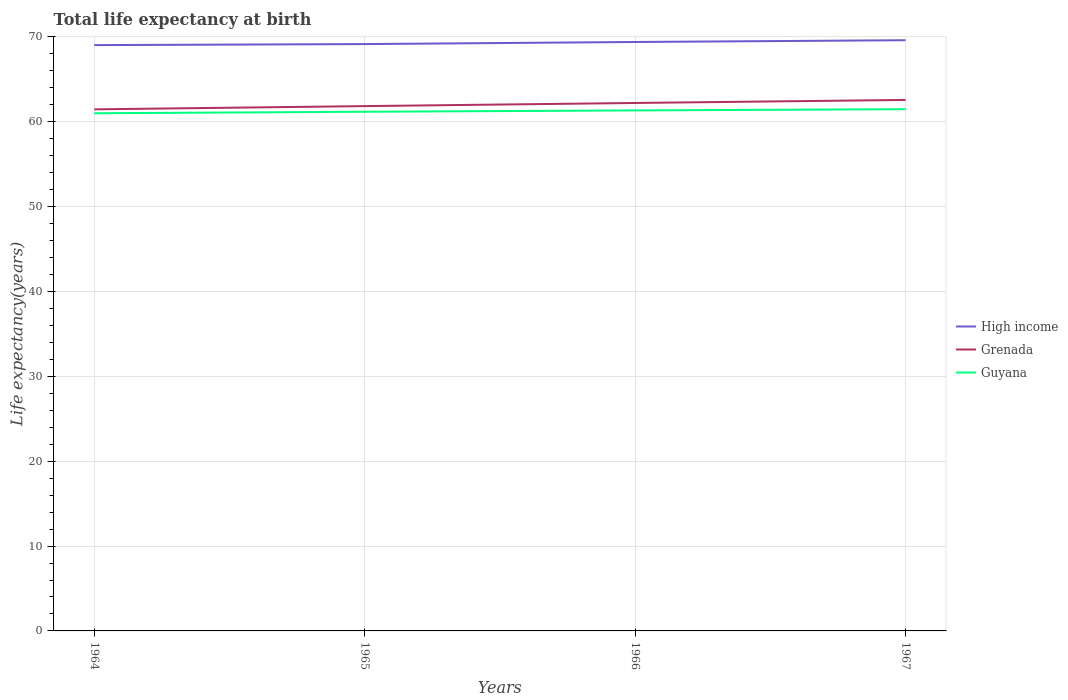Does the line corresponding to High income intersect with the line corresponding to Grenada?
Your answer should be very brief. No. Across all years, what is the maximum life expectancy at birth in in High income?
Provide a short and direct response. 69.04. In which year was the life expectancy at birth in in High income maximum?
Give a very brief answer. 1964. What is the total life expectancy at birth in in Guyana in the graph?
Provide a succinct answer. -0.3. What is the difference between the highest and the second highest life expectancy at birth in in High income?
Ensure brevity in your answer.  0.58. Is the life expectancy at birth in in Grenada strictly greater than the life expectancy at birth in in Guyana over the years?
Provide a short and direct response. No. How many lines are there?
Your answer should be very brief. 3. How many years are there in the graph?
Keep it short and to the point. 4. What is the difference between two consecutive major ticks on the Y-axis?
Make the answer very short. 10. Does the graph contain any zero values?
Make the answer very short. No. How many legend labels are there?
Keep it short and to the point. 3. How are the legend labels stacked?
Offer a terse response. Vertical. What is the title of the graph?
Make the answer very short. Total life expectancy at birth. Does "Iceland" appear as one of the legend labels in the graph?
Your answer should be compact. No. What is the label or title of the Y-axis?
Offer a terse response. Life expectancy(years). What is the Life expectancy(years) of High income in 1964?
Make the answer very short. 69.04. What is the Life expectancy(years) in Grenada in 1964?
Provide a short and direct response. 61.47. What is the Life expectancy(years) in Guyana in 1964?
Give a very brief answer. 61.01. What is the Life expectancy(years) in High income in 1965?
Keep it short and to the point. 69.16. What is the Life expectancy(years) in Grenada in 1965?
Your response must be concise. 61.85. What is the Life expectancy(years) of Guyana in 1965?
Give a very brief answer. 61.19. What is the Life expectancy(years) of High income in 1966?
Offer a terse response. 69.41. What is the Life expectancy(years) of Grenada in 1966?
Provide a short and direct response. 62.22. What is the Life expectancy(years) in Guyana in 1966?
Ensure brevity in your answer.  61.35. What is the Life expectancy(years) of High income in 1967?
Make the answer very short. 69.62. What is the Life expectancy(years) in Grenada in 1967?
Your answer should be very brief. 62.58. What is the Life expectancy(years) of Guyana in 1967?
Give a very brief answer. 61.49. Across all years, what is the maximum Life expectancy(years) of High income?
Give a very brief answer. 69.62. Across all years, what is the maximum Life expectancy(years) of Grenada?
Your answer should be compact. 62.58. Across all years, what is the maximum Life expectancy(years) in Guyana?
Offer a very short reply. 61.49. Across all years, what is the minimum Life expectancy(years) in High income?
Provide a short and direct response. 69.04. Across all years, what is the minimum Life expectancy(years) in Grenada?
Your response must be concise. 61.47. Across all years, what is the minimum Life expectancy(years) in Guyana?
Keep it short and to the point. 61.01. What is the total Life expectancy(years) of High income in the graph?
Your response must be concise. 277.24. What is the total Life expectancy(years) of Grenada in the graph?
Your response must be concise. 248.13. What is the total Life expectancy(years) of Guyana in the graph?
Provide a short and direct response. 245.04. What is the difference between the Life expectancy(years) of High income in 1964 and that in 1965?
Ensure brevity in your answer.  -0.12. What is the difference between the Life expectancy(years) of Grenada in 1964 and that in 1965?
Give a very brief answer. -0.38. What is the difference between the Life expectancy(years) of Guyana in 1964 and that in 1965?
Offer a terse response. -0.17. What is the difference between the Life expectancy(years) in High income in 1964 and that in 1966?
Offer a very short reply. -0.37. What is the difference between the Life expectancy(years) in Grenada in 1964 and that in 1966?
Provide a short and direct response. -0.75. What is the difference between the Life expectancy(years) in Guyana in 1964 and that in 1966?
Keep it short and to the point. -0.34. What is the difference between the Life expectancy(years) of High income in 1964 and that in 1967?
Ensure brevity in your answer.  -0.58. What is the difference between the Life expectancy(years) of Grenada in 1964 and that in 1967?
Provide a succinct answer. -1.11. What is the difference between the Life expectancy(years) of Guyana in 1964 and that in 1967?
Provide a short and direct response. -0.48. What is the difference between the Life expectancy(years) of High income in 1965 and that in 1966?
Offer a very short reply. -0.25. What is the difference between the Life expectancy(years) in Grenada in 1965 and that in 1966?
Your answer should be compact. -0.37. What is the difference between the Life expectancy(years) in Guyana in 1965 and that in 1966?
Offer a terse response. -0.16. What is the difference between the Life expectancy(years) of High income in 1965 and that in 1967?
Keep it short and to the point. -0.45. What is the difference between the Life expectancy(years) in Grenada in 1965 and that in 1967?
Keep it short and to the point. -0.73. What is the difference between the Life expectancy(years) in Guyana in 1965 and that in 1967?
Your response must be concise. -0.3. What is the difference between the Life expectancy(years) of High income in 1966 and that in 1967?
Your answer should be very brief. -0.21. What is the difference between the Life expectancy(years) of Grenada in 1966 and that in 1967?
Your answer should be compact. -0.36. What is the difference between the Life expectancy(years) of Guyana in 1966 and that in 1967?
Provide a short and direct response. -0.14. What is the difference between the Life expectancy(years) in High income in 1964 and the Life expectancy(years) in Grenada in 1965?
Provide a succinct answer. 7.19. What is the difference between the Life expectancy(years) of High income in 1964 and the Life expectancy(years) of Guyana in 1965?
Ensure brevity in your answer.  7.86. What is the difference between the Life expectancy(years) in Grenada in 1964 and the Life expectancy(years) in Guyana in 1965?
Provide a short and direct response. 0.28. What is the difference between the Life expectancy(years) in High income in 1964 and the Life expectancy(years) in Grenada in 1966?
Provide a short and direct response. 6.82. What is the difference between the Life expectancy(years) in High income in 1964 and the Life expectancy(years) in Guyana in 1966?
Offer a terse response. 7.7. What is the difference between the Life expectancy(years) of Grenada in 1964 and the Life expectancy(years) of Guyana in 1966?
Make the answer very short. 0.12. What is the difference between the Life expectancy(years) in High income in 1964 and the Life expectancy(years) in Grenada in 1967?
Your answer should be very brief. 6.46. What is the difference between the Life expectancy(years) of High income in 1964 and the Life expectancy(years) of Guyana in 1967?
Your answer should be compact. 7.55. What is the difference between the Life expectancy(years) of Grenada in 1964 and the Life expectancy(years) of Guyana in 1967?
Your response must be concise. -0.02. What is the difference between the Life expectancy(years) of High income in 1965 and the Life expectancy(years) of Grenada in 1966?
Your answer should be very brief. 6.94. What is the difference between the Life expectancy(years) in High income in 1965 and the Life expectancy(years) in Guyana in 1966?
Provide a succinct answer. 7.82. What is the difference between the Life expectancy(years) in Grenada in 1965 and the Life expectancy(years) in Guyana in 1966?
Your response must be concise. 0.51. What is the difference between the Life expectancy(years) in High income in 1965 and the Life expectancy(years) in Grenada in 1967?
Make the answer very short. 6.58. What is the difference between the Life expectancy(years) of High income in 1965 and the Life expectancy(years) of Guyana in 1967?
Offer a terse response. 7.67. What is the difference between the Life expectancy(years) in Grenada in 1965 and the Life expectancy(years) in Guyana in 1967?
Your response must be concise. 0.36. What is the difference between the Life expectancy(years) in High income in 1966 and the Life expectancy(years) in Grenada in 1967?
Make the answer very short. 6.83. What is the difference between the Life expectancy(years) of High income in 1966 and the Life expectancy(years) of Guyana in 1967?
Provide a succinct answer. 7.92. What is the difference between the Life expectancy(years) in Grenada in 1966 and the Life expectancy(years) in Guyana in 1967?
Keep it short and to the point. 0.73. What is the average Life expectancy(years) in High income per year?
Provide a succinct answer. 69.31. What is the average Life expectancy(years) of Grenada per year?
Provide a succinct answer. 62.03. What is the average Life expectancy(years) in Guyana per year?
Offer a terse response. 61.26. In the year 1964, what is the difference between the Life expectancy(years) in High income and Life expectancy(years) in Grenada?
Give a very brief answer. 7.57. In the year 1964, what is the difference between the Life expectancy(years) of High income and Life expectancy(years) of Guyana?
Provide a short and direct response. 8.03. In the year 1964, what is the difference between the Life expectancy(years) of Grenada and Life expectancy(years) of Guyana?
Offer a terse response. 0.46. In the year 1965, what is the difference between the Life expectancy(years) in High income and Life expectancy(years) in Grenada?
Provide a succinct answer. 7.31. In the year 1965, what is the difference between the Life expectancy(years) in High income and Life expectancy(years) in Guyana?
Your answer should be very brief. 7.98. In the year 1965, what is the difference between the Life expectancy(years) in Grenada and Life expectancy(years) in Guyana?
Ensure brevity in your answer.  0.67. In the year 1966, what is the difference between the Life expectancy(years) of High income and Life expectancy(years) of Grenada?
Your answer should be compact. 7.19. In the year 1966, what is the difference between the Life expectancy(years) of High income and Life expectancy(years) of Guyana?
Provide a short and direct response. 8.06. In the year 1966, what is the difference between the Life expectancy(years) of Grenada and Life expectancy(years) of Guyana?
Your response must be concise. 0.88. In the year 1967, what is the difference between the Life expectancy(years) in High income and Life expectancy(years) in Grenada?
Provide a succinct answer. 7.04. In the year 1967, what is the difference between the Life expectancy(years) in High income and Life expectancy(years) in Guyana?
Make the answer very short. 8.13. In the year 1967, what is the difference between the Life expectancy(years) in Grenada and Life expectancy(years) in Guyana?
Your answer should be very brief. 1.09. What is the ratio of the Life expectancy(years) of High income in 1964 to that in 1965?
Provide a succinct answer. 1. What is the ratio of the Life expectancy(years) of Grenada in 1964 to that in 1965?
Give a very brief answer. 0.99. What is the ratio of the Life expectancy(years) of Guyana in 1964 to that in 1965?
Make the answer very short. 1. What is the ratio of the Life expectancy(years) in High income in 1964 to that in 1966?
Provide a succinct answer. 0.99. What is the ratio of the Life expectancy(years) in Grenada in 1964 to that in 1966?
Give a very brief answer. 0.99. What is the ratio of the Life expectancy(years) in Guyana in 1964 to that in 1966?
Make the answer very short. 0.99. What is the ratio of the Life expectancy(years) of Grenada in 1964 to that in 1967?
Give a very brief answer. 0.98. What is the ratio of the Life expectancy(years) in Grenada in 1965 to that in 1966?
Offer a terse response. 0.99. What is the ratio of the Life expectancy(years) of Guyana in 1965 to that in 1966?
Keep it short and to the point. 1. What is the ratio of the Life expectancy(years) of Grenada in 1965 to that in 1967?
Offer a terse response. 0.99. What is the ratio of the Life expectancy(years) of Guyana in 1965 to that in 1967?
Provide a short and direct response. 1. What is the ratio of the Life expectancy(years) of High income in 1966 to that in 1967?
Provide a short and direct response. 1. What is the ratio of the Life expectancy(years) of Guyana in 1966 to that in 1967?
Your answer should be very brief. 1. What is the difference between the highest and the second highest Life expectancy(years) of High income?
Offer a very short reply. 0.21. What is the difference between the highest and the second highest Life expectancy(years) of Grenada?
Offer a terse response. 0.36. What is the difference between the highest and the second highest Life expectancy(years) of Guyana?
Your response must be concise. 0.14. What is the difference between the highest and the lowest Life expectancy(years) of High income?
Keep it short and to the point. 0.58. What is the difference between the highest and the lowest Life expectancy(years) of Grenada?
Offer a terse response. 1.11. What is the difference between the highest and the lowest Life expectancy(years) of Guyana?
Your response must be concise. 0.48. 